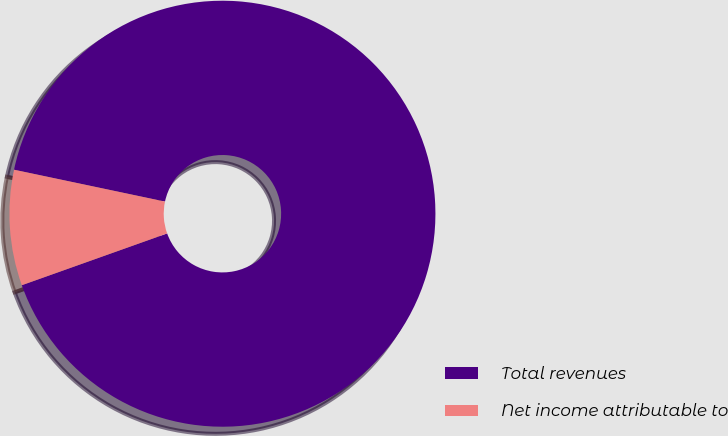Convert chart to OTSL. <chart><loc_0><loc_0><loc_500><loc_500><pie_chart><fcel>Total revenues<fcel>Net income attributable to<nl><fcel>91.24%<fcel>8.76%<nl></chart> 